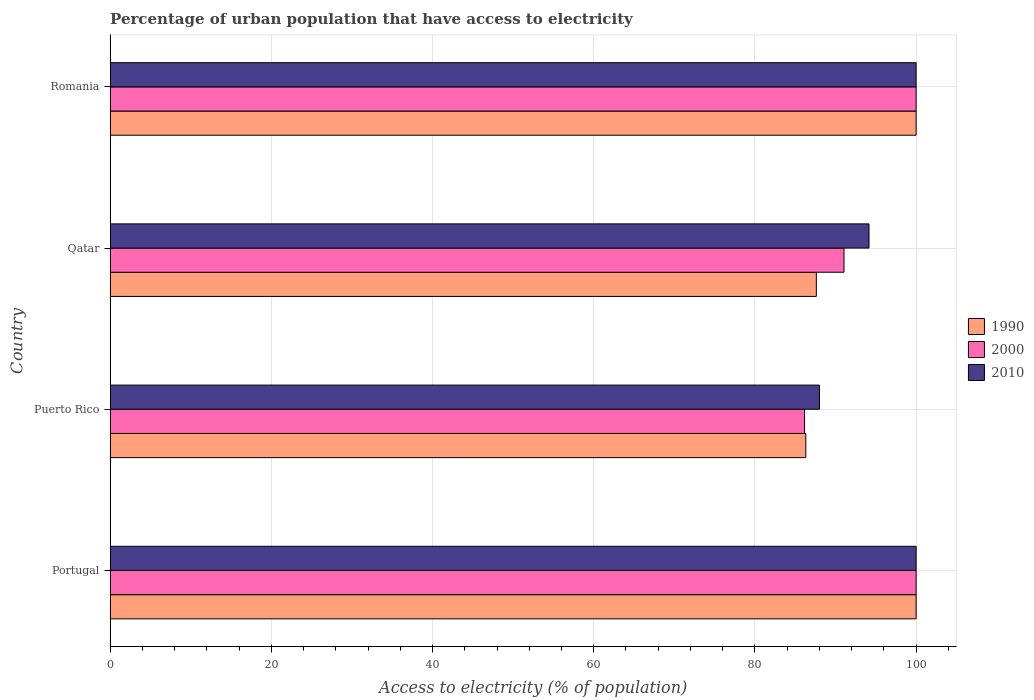Are the number of bars per tick equal to the number of legend labels?
Your answer should be compact. Yes. Are the number of bars on each tick of the Y-axis equal?
Give a very brief answer. Yes. How many bars are there on the 1st tick from the top?
Give a very brief answer. 3. What is the label of the 3rd group of bars from the top?
Give a very brief answer. Puerto Rico. What is the percentage of urban population that have access to electricity in 2010 in Puerto Rico?
Your answer should be very brief. 88.01. Across all countries, what is the maximum percentage of urban population that have access to electricity in 2010?
Provide a succinct answer. 100. Across all countries, what is the minimum percentage of urban population that have access to electricity in 2010?
Keep it short and to the point. 88.01. In which country was the percentage of urban population that have access to electricity in 2010 minimum?
Your answer should be compact. Puerto Rico. What is the total percentage of urban population that have access to electricity in 1990 in the graph?
Keep it short and to the point. 373.93. What is the difference between the percentage of urban population that have access to electricity in 2000 in Puerto Rico and that in Romania?
Your answer should be very brief. -13.85. What is the difference between the percentage of urban population that have access to electricity in 2010 in Puerto Rico and the percentage of urban population that have access to electricity in 1990 in Portugal?
Give a very brief answer. -11.99. What is the average percentage of urban population that have access to electricity in 2010 per country?
Your response must be concise. 95.54. What is the difference between the percentage of urban population that have access to electricity in 2010 and percentage of urban population that have access to electricity in 1990 in Puerto Rico?
Make the answer very short. 1.7. In how many countries, is the percentage of urban population that have access to electricity in 1990 greater than 12 %?
Offer a very short reply. 4. What is the ratio of the percentage of urban population that have access to electricity in 1990 in Portugal to that in Puerto Rico?
Your response must be concise. 1.16. Is the difference between the percentage of urban population that have access to electricity in 2010 in Portugal and Puerto Rico greater than the difference between the percentage of urban population that have access to electricity in 1990 in Portugal and Puerto Rico?
Keep it short and to the point. No. What is the difference between the highest and the lowest percentage of urban population that have access to electricity in 2010?
Give a very brief answer. 11.99. In how many countries, is the percentage of urban population that have access to electricity in 2000 greater than the average percentage of urban population that have access to electricity in 2000 taken over all countries?
Your response must be concise. 2. What does the 2nd bar from the top in Romania represents?
Your answer should be compact. 2000. How many bars are there?
Your answer should be compact. 12. What is the difference between two consecutive major ticks on the X-axis?
Provide a succinct answer. 20. Are the values on the major ticks of X-axis written in scientific E-notation?
Offer a terse response. No. Does the graph contain any zero values?
Offer a terse response. No. Where does the legend appear in the graph?
Offer a terse response. Center right. What is the title of the graph?
Offer a very short reply. Percentage of urban population that have access to electricity. Does "1989" appear as one of the legend labels in the graph?
Ensure brevity in your answer.  No. What is the label or title of the X-axis?
Make the answer very short. Access to electricity (% of population). What is the label or title of the Y-axis?
Offer a very short reply. Country. What is the Access to electricity (% of population) in 1990 in Portugal?
Your response must be concise. 100. What is the Access to electricity (% of population) in 2010 in Portugal?
Keep it short and to the point. 100. What is the Access to electricity (% of population) of 1990 in Puerto Rico?
Offer a very short reply. 86.31. What is the Access to electricity (% of population) in 2000 in Puerto Rico?
Offer a very short reply. 86.15. What is the Access to electricity (% of population) in 2010 in Puerto Rico?
Provide a succinct answer. 88.01. What is the Access to electricity (% of population) of 1990 in Qatar?
Offer a terse response. 87.62. What is the Access to electricity (% of population) in 2000 in Qatar?
Your answer should be compact. 91.05. What is the Access to electricity (% of population) in 2010 in Qatar?
Provide a succinct answer. 94.15. What is the Access to electricity (% of population) of 2000 in Romania?
Your answer should be compact. 100. What is the Access to electricity (% of population) in 2010 in Romania?
Your response must be concise. 100. Across all countries, what is the maximum Access to electricity (% of population) of 2010?
Make the answer very short. 100. Across all countries, what is the minimum Access to electricity (% of population) of 1990?
Offer a very short reply. 86.31. Across all countries, what is the minimum Access to electricity (% of population) of 2000?
Provide a succinct answer. 86.15. Across all countries, what is the minimum Access to electricity (% of population) in 2010?
Provide a succinct answer. 88.01. What is the total Access to electricity (% of population) of 1990 in the graph?
Offer a terse response. 373.93. What is the total Access to electricity (% of population) of 2000 in the graph?
Your response must be concise. 377.21. What is the total Access to electricity (% of population) of 2010 in the graph?
Keep it short and to the point. 382.16. What is the difference between the Access to electricity (% of population) of 1990 in Portugal and that in Puerto Rico?
Give a very brief answer. 13.69. What is the difference between the Access to electricity (% of population) of 2000 in Portugal and that in Puerto Rico?
Provide a short and direct response. 13.85. What is the difference between the Access to electricity (% of population) in 2010 in Portugal and that in Puerto Rico?
Ensure brevity in your answer.  11.99. What is the difference between the Access to electricity (% of population) in 1990 in Portugal and that in Qatar?
Provide a short and direct response. 12.38. What is the difference between the Access to electricity (% of population) of 2000 in Portugal and that in Qatar?
Your response must be concise. 8.95. What is the difference between the Access to electricity (% of population) in 2010 in Portugal and that in Qatar?
Your response must be concise. 5.85. What is the difference between the Access to electricity (% of population) of 2010 in Portugal and that in Romania?
Make the answer very short. 0. What is the difference between the Access to electricity (% of population) of 1990 in Puerto Rico and that in Qatar?
Offer a very short reply. -1.31. What is the difference between the Access to electricity (% of population) in 2000 in Puerto Rico and that in Qatar?
Offer a terse response. -4.9. What is the difference between the Access to electricity (% of population) in 2010 in Puerto Rico and that in Qatar?
Offer a very short reply. -6.15. What is the difference between the Access to electricity (% of population) of 1990 in Puerto Rico and that in Romania?
Your answer should be very brief. -13.69. What is the difference between the Access to electricity (% of population) of 2000 in Puerto Rico and that in Romania?
Offer a terse response. -13.85. What is the difference between the Access to electricity (% of population) in 2010 in Puerto Rico and that in Romania?
Your answer should be compact. -11.99. What is the difference between the Access to electricity (% of population) of 1990 in Qatar and that in Romania?
Offer a very short reply. -12.38. What is the difference between the Access to electricity (% of population) of 2000 in Qatar and that in Romania?
Make the answer very short. -8.95. What is the difference between the Access to electricity (% of population) of 2010 in Qatar and that in Romania?
Make the answer very short. -5.85. What is the difference between the Access to electricity (% of population) of 1990 in Portugal and the Access to electricity (% of population) of 2000 in Puerto Rico?
Your response must be concise. 13.85. What is the difference between the Access to electricity (% of population) in 1990 in Portugal and the Access to electricity (% of population) in 2010 in Puerto Rico?
Offer a very short reply. 11.99. What is the difference between the Access to electricity (% of population) of 2000 in Portugal and the Access to electricity (% of population) of 2010 in Puerto Rico?
Give a very brief answer. 11.99. What is the difference between the Access to electricity (% of population) of 1990 in Portugal and the Access to electricity (% of population) of 2000 in Qatar?
Give a very brief answer. 8.95. What is the difference between the Access to electricity (% of population) of 1990 in Portugal and the Access to electricity (% of population) of 2010 in Qatar?
Offer a very short reply. 5.85. What is the difference between the Access to electricity (% of population) of 2000 in Portugal and the Access to electricity (% of population) of 2010 in Qatar?
Provide a succinct answer. 5.85. What is the difference between the Access to electricity (% of population) of 1990 in Portugal and the Access to electricity (% of population) of 2000 in Romania?
Provide a short and direct response. 0. What is the difference between the Access to electricity (% of population) in 1990 in Portugal and the Access to electricity (% of population) in 2010 in Romania?
Your answer should be very brief. 0. What is the difference between the Access to electricity (% of population) in 1990 in Puerto Rico and the Access to electricity (% of population) in 2000 in Qatar?
Your response must be concise. -4.74. What is the difference between the Access to electricity (% of population) of 1990 in Puerto Rico and the Access to electricity (% of population) of 2010 in Qatar?
Provide a short and direct response. -7.84. What is the difference between the Access to electricity (% of population) of 2000 in Puerto Rico and the Access to electricity (% of population) of 2010 in Qatar?
Your answer should be compact. -8. What is the difference between the Access to electricity (% of population) of 1990 in Puerto Rico and the Access to electricity (% of population) of 2000 in Romania?
Your answer should be very brief. -13.69. What is the difference between the Access to electricity (% of population) in 1990 in Puerto Rico and the Access to electricity (% of population) in 2010 in Romania?
Your response must be concise. -13.69. What is the difference between the Access to electricity (% of population) of 2000 in Puerto Rico and the Access to electricity (% of population) of 2010 in Romania?
Your response must be concise. -13.85. What is the difference between the Access to electricity (% of population) in 1990 in Qatar and the Access to electricity (% of population) in 2000 in Romania?
Offer a very short reply. -12.38. What is the difference between the Access to electricity (% of population) of 1990 in Qatar and the Access to electricity (% of population) of 2010 in Romania?
Ensure brevity in your answer.  -12.38. What is the difference between the Access to electricity (% of population) of 2000 in Qatar and the Access to electricity (% of population) of 2010 in Romania?
Ensure brevity in your answer.  -8.95. What is the average Access to electricity (% of population) in 1990 per country?
Provide a short and direct response. 93.48. What is the average Access to electricity (% of population) of 2000 per country?
Offer a very short reply. 94.3. What is the average Access to electricity (% of population) of 2010 per country?
Your answer should be very brief. 95.54. What is the difference between the Access to electricity (% of population) of 2000 and Access to electricity (% of population) of 2010 in Portugal?
Your answer should be very brief. 0. What is the difference between the Access to electricity (% of population) in 1990 and Access to electricity (% of population) in 2000 in Puerto Rico?
Your answer should be very brief. 0.16. What is the difference between the Access to electricity (% of population) of 1990 and Access to electricity (% of population) of 2010 in Puerto Rico?
Ensure brevity in your answer.  -1.7. What is the difference between the Access to electricity (% of population) in 2000 and Access to electricity (% of population) in 2010 in Puerto Rico?
Give a very brief answer. -1.85. What is the difference between the Access to electricity (% of population) in 1990 and Access to electricity (% of population) in 2000 in Qatar?
Provide a short and direct response. -3.43. What is the difference between the Access to electricity (% of population) of 1990 and Access to electricity (% of population) of 2010 in Qatar?
Your answer should be very brief. -6.54. What is the difference between the Access to electricity (% of population) of 2000 and Access to electricity (% of population) of 2010 in Qatar?
Your response must be concise. -3.1. What is the difference between the Access to electricity (% of population) in 2000 and Access to electricity (% of population) in 2010 in Romania?
Your response must be concise. 0. What is the ratio of the Access to electricity (% of population) in 1990 in Portugal to that in Puerto Rico?
Give a very brief answer. 1.16. What is the ratio of the Access to electricity (% of population) of 2000 in Portugal to that in Puerto Rico?
Your answer should be compact. 1.16. What is the ratio of the Access to electricity (% of population) in 2010 in Portugal to that in Puerto Rico?
Keep it short and to the point. 1.14. What is the ratio of the Access to electricity (% of population) in 1990 in Portugal to that in Qatar?
Your answer should be very brief. 1.14. What is the ratio of the Access to electricity (% of population) in 2000 in Portugal to that in Qatar?
Provide a short and direct response. 1.1. What is the ratio of the Access to electricity (% of population) in 2010 in Portugal to that in Qatar?
Provide a short and direct response. 1.06. What is the ratio of the Access to electricity (% of population) of 2000 in Portugal to that in Romania?
Provide a short and direct response. 1. What is the ratio of the Access to electricity (% of population) in 2010 in Portugal to that in Romania?
Your answer should be very brief. 1. What is the ratio of the Access to electricity (% of population) of 1990 in Puerto Rico to that in Qatar?
Make the answer very short. 0.99. What is the ratio of the Access to electricity (% of population) in 2000 in Puerto Rico to that in Qatar?
Give a very brief answer. 0.95. What is the ratio of the Access to electricity (% of population) in 2010 in Puerto Rico to that in Qatar?
Keep it short and to the point. 0.93. What is the ratio of the Access to electricity (% of population) of 1990 in Puerto Rico to that in Romania?
Your answer should be compact. 0.86. What is the ratio of the Access to electricity (% of population) of 2000 in Puerto Rico to that in Romania?
Provide a short and direct response. 0.86. What is the ratio of the Access to electricity (% of population) of 2010 in Puerto Rico to that in Romania?
Offer a terse response. 0.88. What is the ratio of the Access to electricity (% of population) in 1990 in Qatar to that in Romania?
Provide a succinct answer. 0.88. What is the ratio of the Access to electricity (% of population) in 2000 in Qatar to that in Romania?
Ensure brevity in your answer.  0.91. What is the ratio of the Access to electricity (% of population) in 2010 in Qatar to that in Romania?
Your response must be concise. 0.94. What is the difference between the highest and the second highest Access to electricity (% of population) in 2000?
Offer a terse response. 0. What is the difference between the highest and the second highest Access to electricity (% of population) of 2010?
Offer a very short reply. 0. What is the difference between the highest and the lowest Access to electricity (% of population) of 1990?
Your answer should be very brief. 13.69. What is the difference between the highest and the lowest Access to electricity (% of population) of 2000?
Your answer should be compact. 13.85. What is the difference between the highest and the lowest Access to electricity (% of population) in 2010?
Keep it short and to the point. 11.99. 